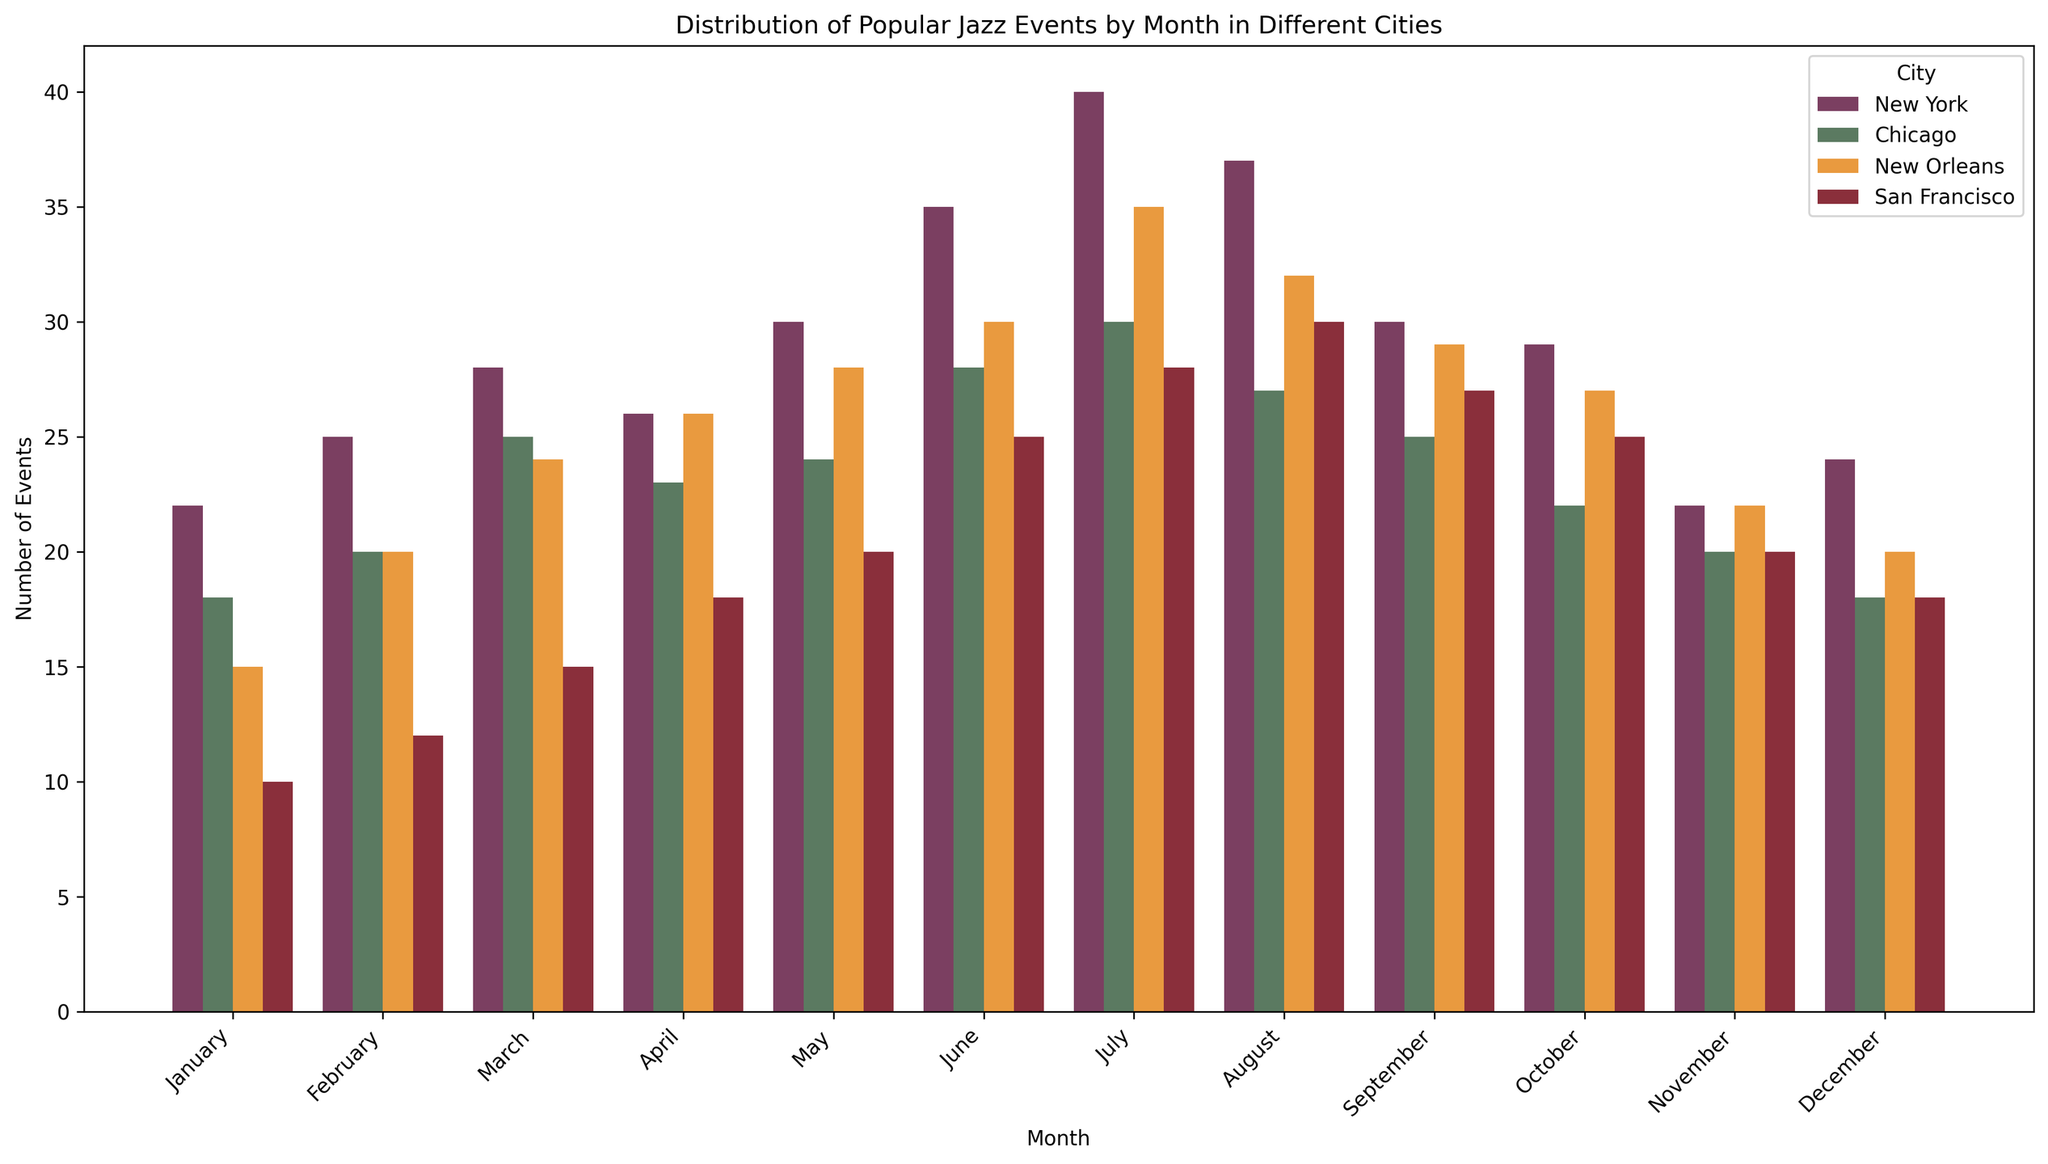How many total Jazz events were held in New York during the summer months (June, July, August)? Sum the number of events for New York in June (35), July (40), and August (37). The total is 35 + 40 + 37 = 112.
Answer: 112 Which city had the highest number of events in July? Compare the number of events in July across all cities: New York (40), Chicago (30), New Orleans (35), and San Francisco (28). New York had the highest number.
Answer: New York In which month did San Francisco hold the fewest Jazz events? Identify the month with the lowest bar for San Francisco. January had the fewest events, with 10.
Answer: January Which city showed the highest increase in the number of events from January to July? Calculate the difference between January and July for each city: New York (40 - 22 = 18), Chicago (30 - 18 = 12), New Orleans (35 - 15 = 20), and San Francisco (28 - 10 = 18). New Orleans showed the highest increase.
Answer: New Orleans What is the average number of Jazz events per month in New Orleans? Sum the number of events for New Orleans across all months and divide by 12. Total is 15 + 20 + 24 + 26 + 28 + 30 + 35 + 32 + 29 + 27 + 22 + 20 = 308. The average is 308 / 12 ≈ 25.67.
Answer: 25.67 How many more Jazz events were held in New York compared to San Francisco in April? Subtract the number of events in April for San Francisco (18) from New York (26). The difference is 26 - 18 = 8.
Answer: 8 During which month does Chicago catch up or exceed New York in the number of Jazz events? Compare the number of events for each month. Chicago never exceeds New York in any month.
Answer: None Which month shows the least variation in the number of Jazz events among the four cities? Check the spread of the number of events for each month among the cities. February appears to have the smallest range: New York (25), Chicago (20), New Orleans (20), San Francisco (12). Range = 25 - 12 = 13.
Answer: February In which month does New Orleans have a peak in the number of Jazz events? Identify the month where New Orleans had the highest bar. It was July, with 35 events.
Answer: July 